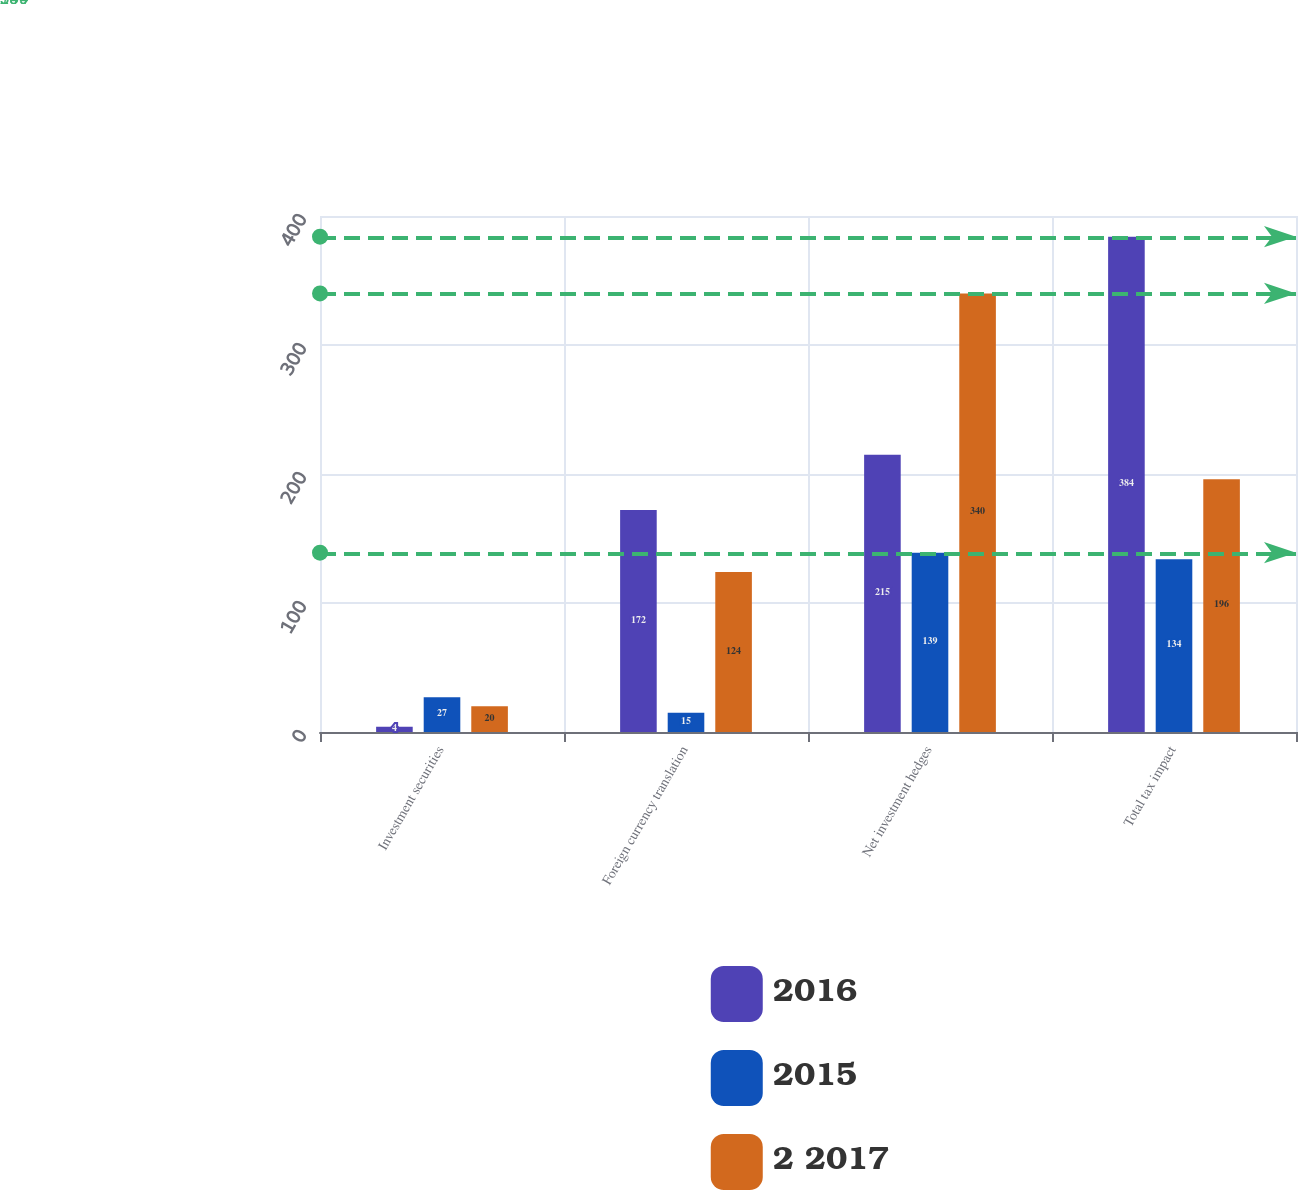<chart> <loc_0><loc_0><loc_500><loc_500><stacked_bar_chart><ecel><fcel>Investment securities<fcel>Foreign currency translation<fcel>Net investment hedges<fcel>Total tax impact<nl><fcel>2016<fcel>4<fcel>172<fcel>215<fcel>384<nl><fcel>2015<fcel>27<fcel>15<fcel>139<fcel>134<nl><fcel>2 2017<fcel>20<fcel>124<fcel>340<fcel>196<nl></chart> 